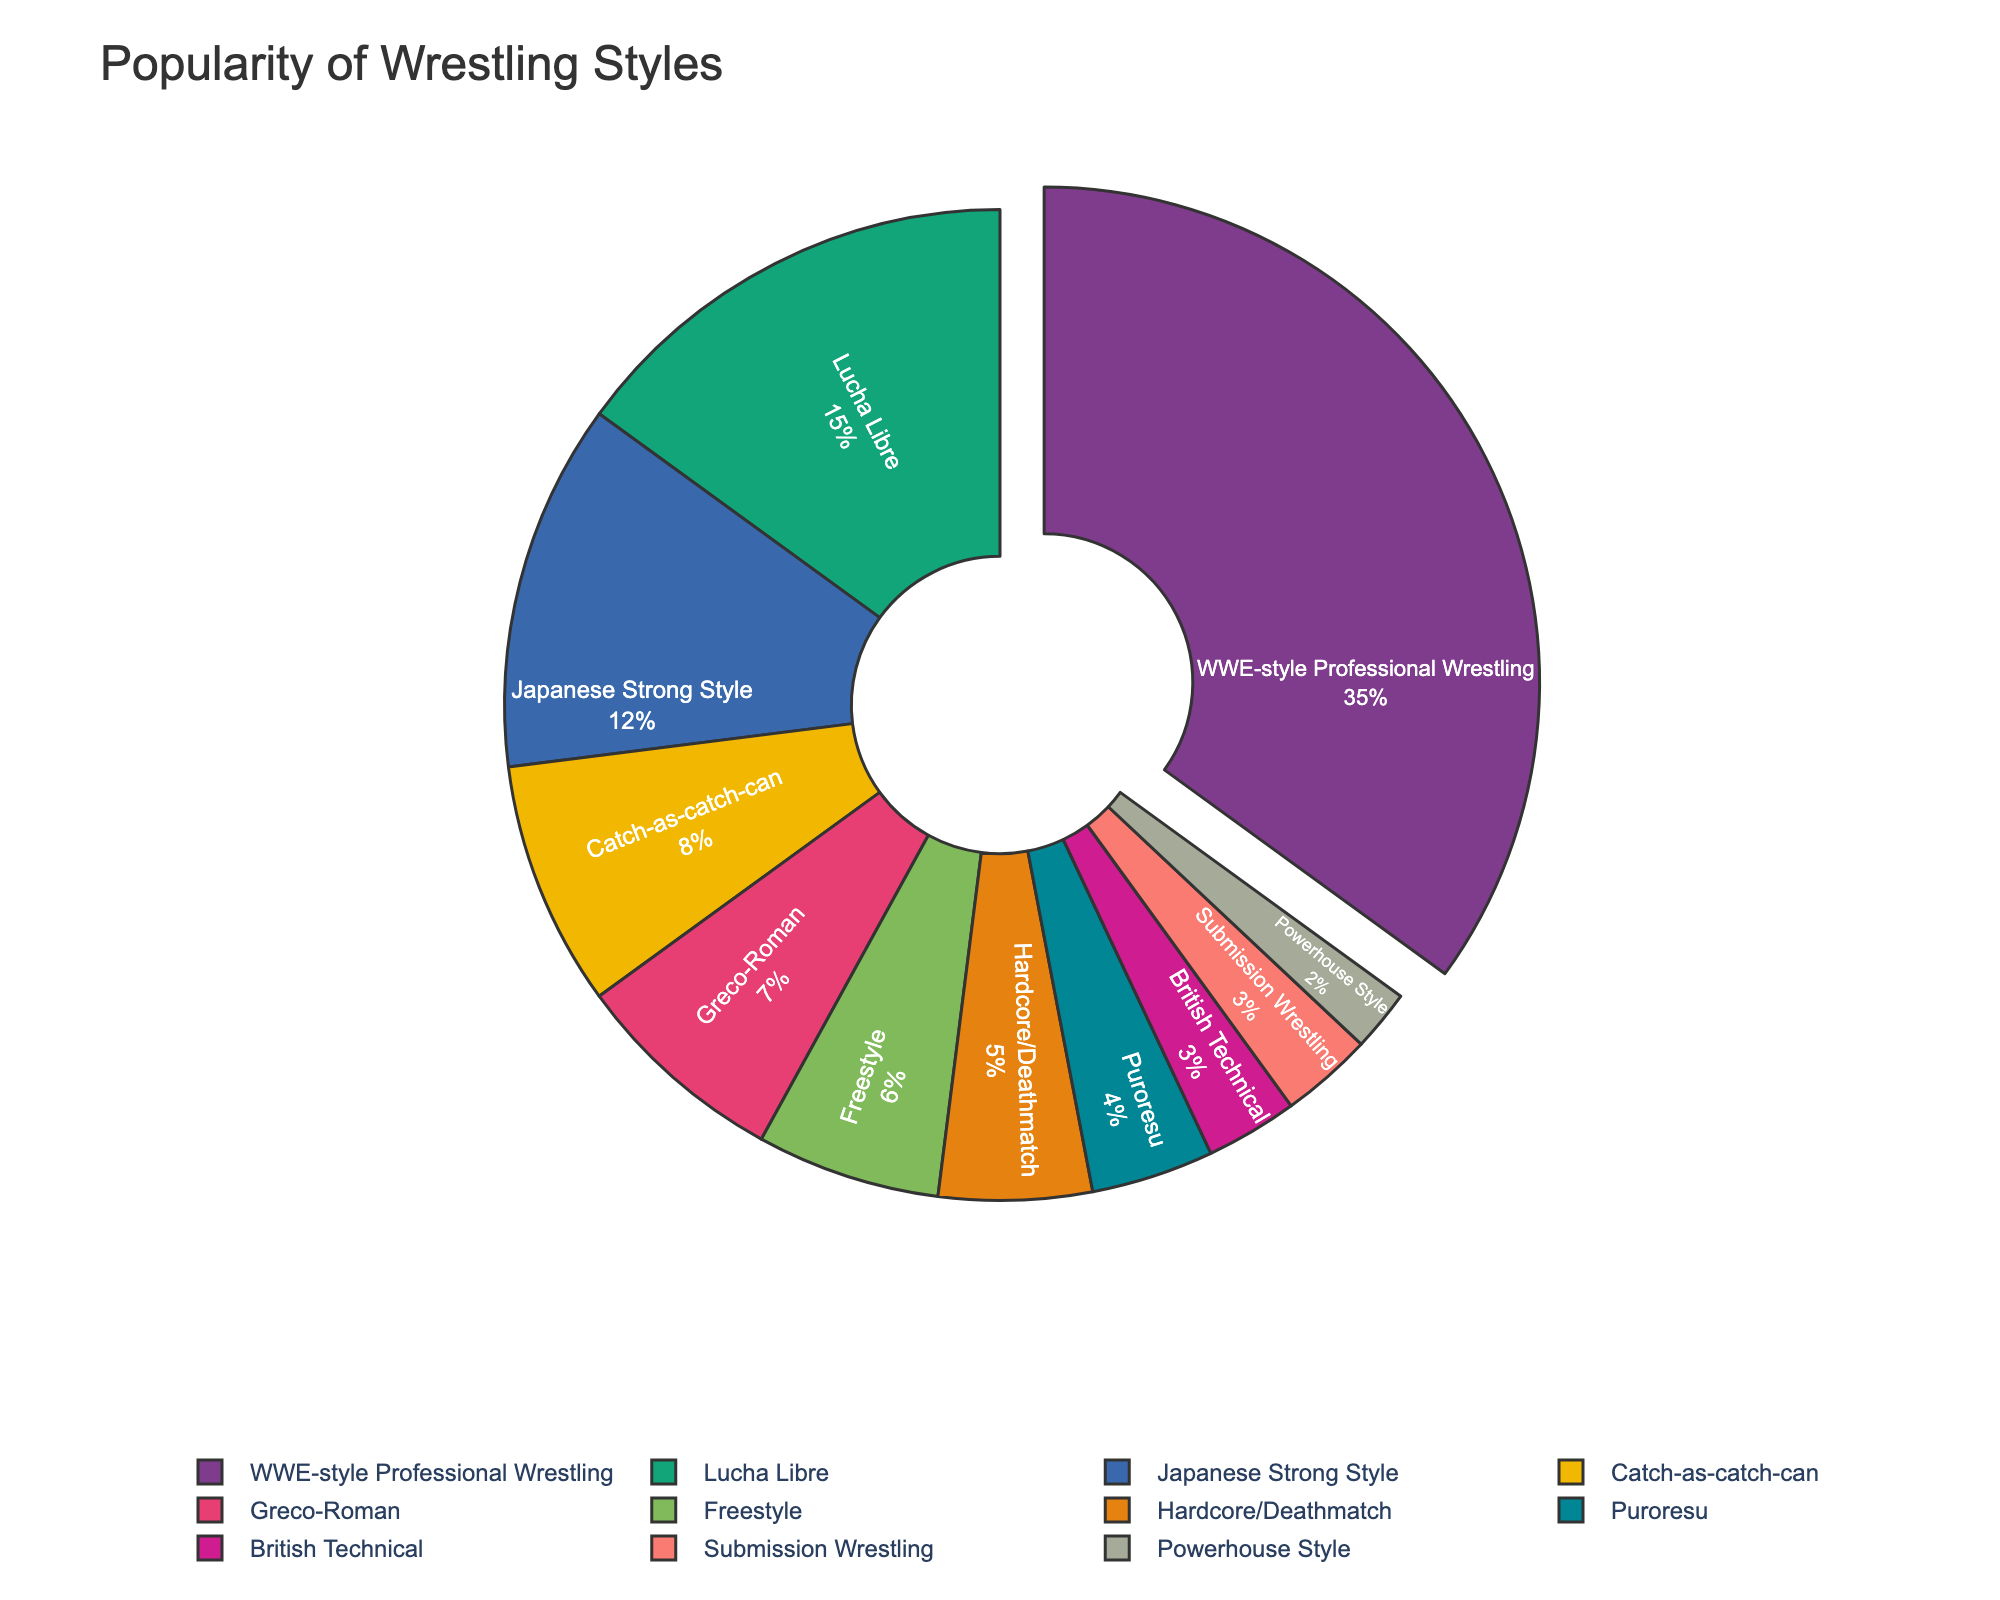what is the most popular wrestling style among fans? The WWE-style Professional Wrestling slice has the largest portion of the pie chart, indicating it has the highest popularity percentage.
Answer: WWE-style Professional Wrestling Which wrestling style is more popular: Lucha Libre or Japanese Strong Style? The pie chart shows that Lucha Libre has a larger slice compared to Japanese Strong Style, indicating a higher popularity percentage for Lucha Libre.
Answer: Lucha Libre What's the combined popularity percentage of Catch-as-catch-can and Greco-Roman wrestling styles? To get the combined popularity percentage, we need to sum the percentages of both Catch-as-catch-can (8) and Greco-Roman (7). The combined percentage is 8 + 7 = 15.
Answer: 15 Is the popularity of Freestyle wrestling greater than 5%? The Freestyle slice in the pie chart indicates a percentage of 6, which is indeed greater than 5%.
Answer: Yes Which wrestling style has the smallest popularity percentage? The Powerhouse Style slice is the smallest in the pie chart, indicating it has the lowest popularity percentage.
Answer: Powerhouse Style How much more popular is WWE-style Professional Wrestling compared to Hardcore/Deathmatch? WWE-style Professional Wrestling has a popularity of 35%, while Hardcore/Deathmatch has 5%. The difference is 35 - 5 = 30.
Answer: 30 What's the difference in popularity between British Technical and Submission Wrestling? Both British Technical and Submission Wrestling have a popularity percentage of 3 each. The difference is 3 - 3 = 0.
Answer: 0 Which style forms 12% of the overall popularity? The pie chart segment labeled Japanese Strong Style represents 12% of the overall popularity.
Answer: Japanese Strong Style 